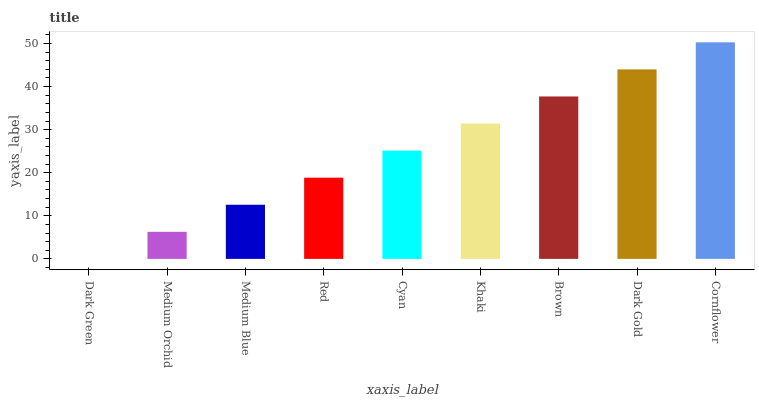Is Medium Orchid the minimum?
Answer yes or no. No. Is Medium Orchid the maximum?
Answer yes or no. No. Is Medium Orchid greater than Dark Green?
Answer yes or no. Yes. Is Dark Green less than Medium Orchid?
Answer yes or no. Yes. Is Dark Green greater than Medium Orchid?
Answer yes or no. No. Is Medium Orchid less than Dark Green?
Answer yes or no. No. Is Cyan the high median?
Answer yes or no. Yes. Is Cyan the low median?
Answer yes or no. Yes. Is Medium Blue the high median?
Answer yes or no. No. Is Cornflower the low median?
Answer yes or no. No. 